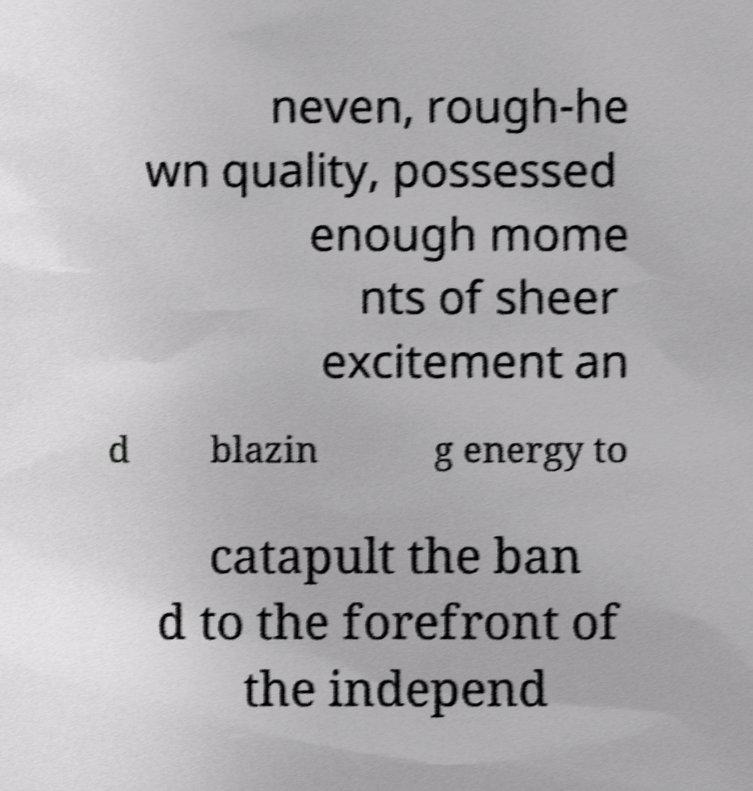Could you assist in decoding the text presented in this image and type it out clearly? neven, rough-he wn quality, possessed enough mome nts of sheer excitement an d blazin g energy to catapult the ban d to the forefront of the independ 